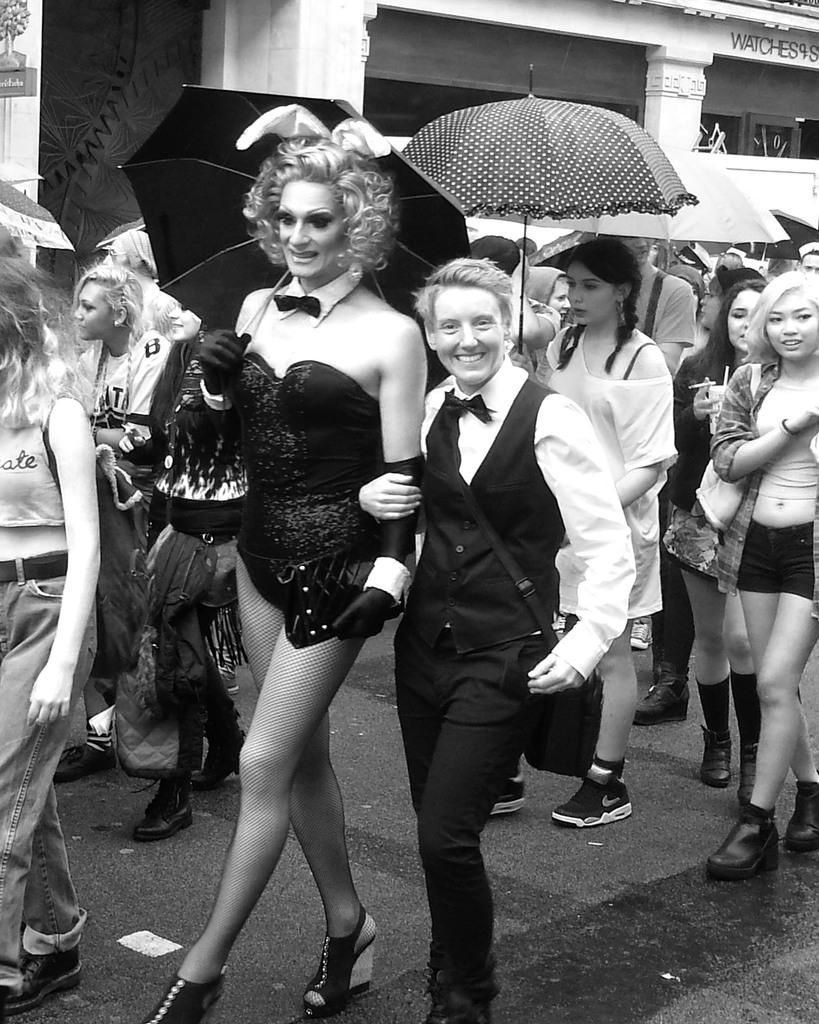How would you summarize this image in a sentence or two? This is a black and white image. There are so many persons in the middle, who are walking. Some of them are holding umbrellas. There is a building backside. 